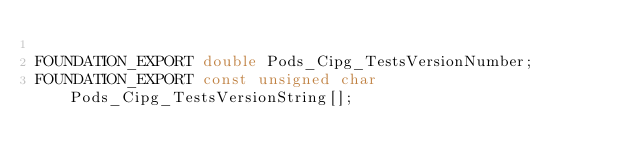<code> <loc_0><loc_0><loc_500><loc_500><_C_>
FOUNDATION_EXPORT double Pods_Cipg_TestsVersionNumber;
FOUNDATION_EXPORT const unsigned char Pods_Cipg_TestsVersionString[];

</code> 